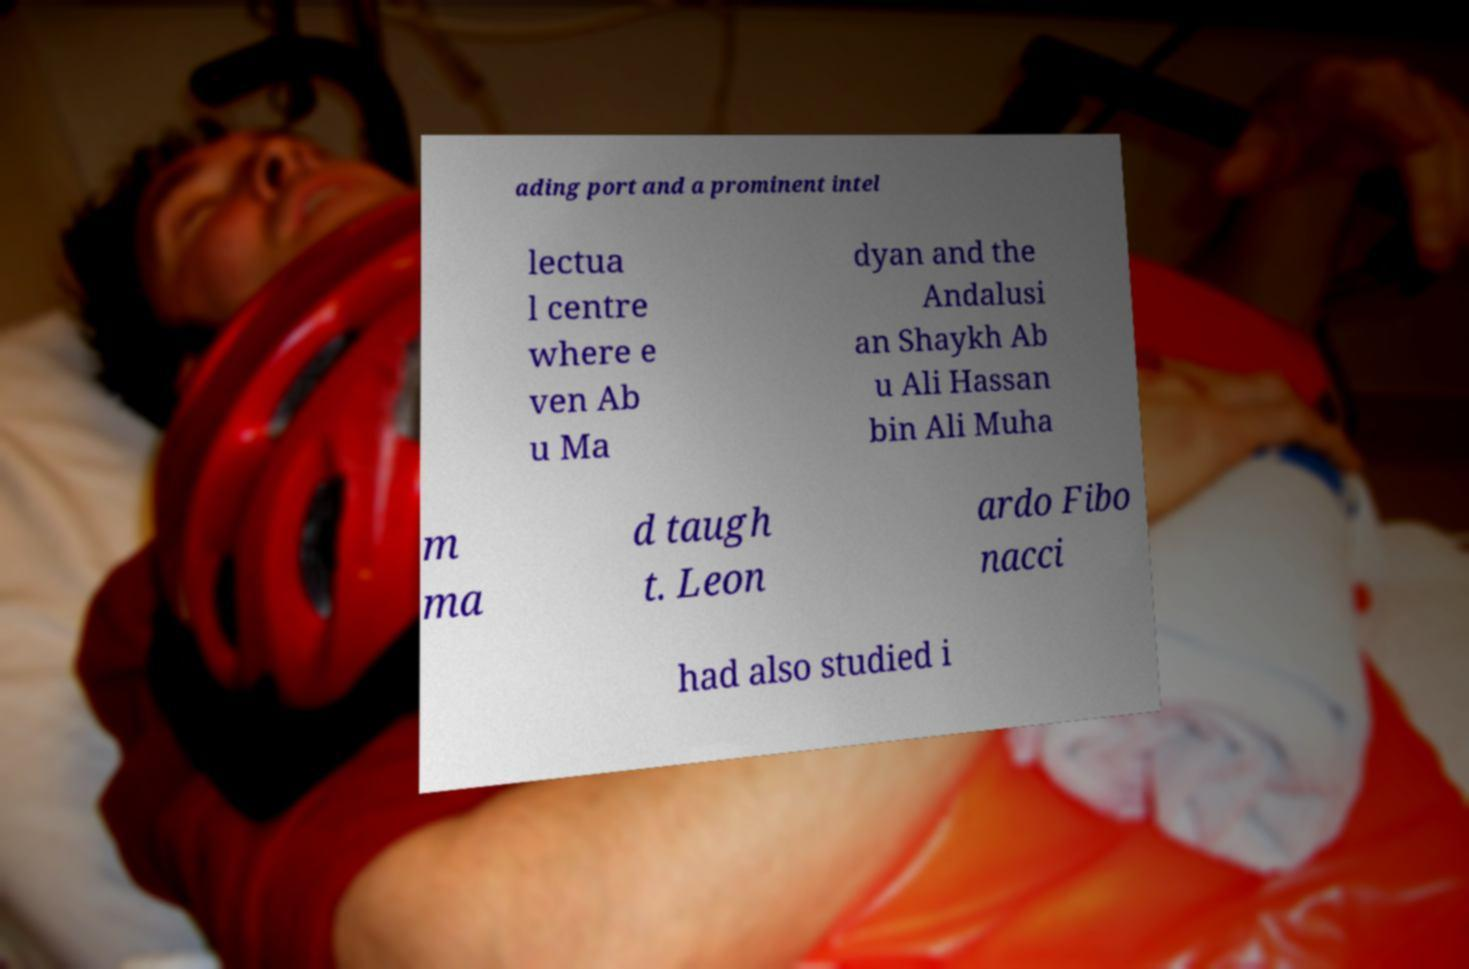Could you extract and type out the text from this image? ading port and a prominent intel lectua l centre where e ven Ab u Ma dyan and the Andalusi an Shaykh Ab u Ali Hassan bin Ali Muha m ma d taugh t. Leon ardo Fibo nacci had also studied i 